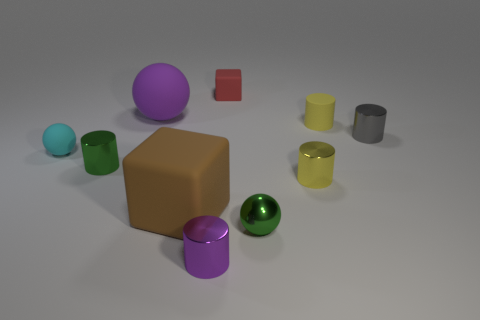Can you describe the shapes and colors of the objects in this image? Certainly! The image features a variety of geometric shapes including a large purple sphere, a sizable brown cube, smaller cylinders in yellow, silver, and green, as well as a small red cube and a tiny aqua-colored sphere. 